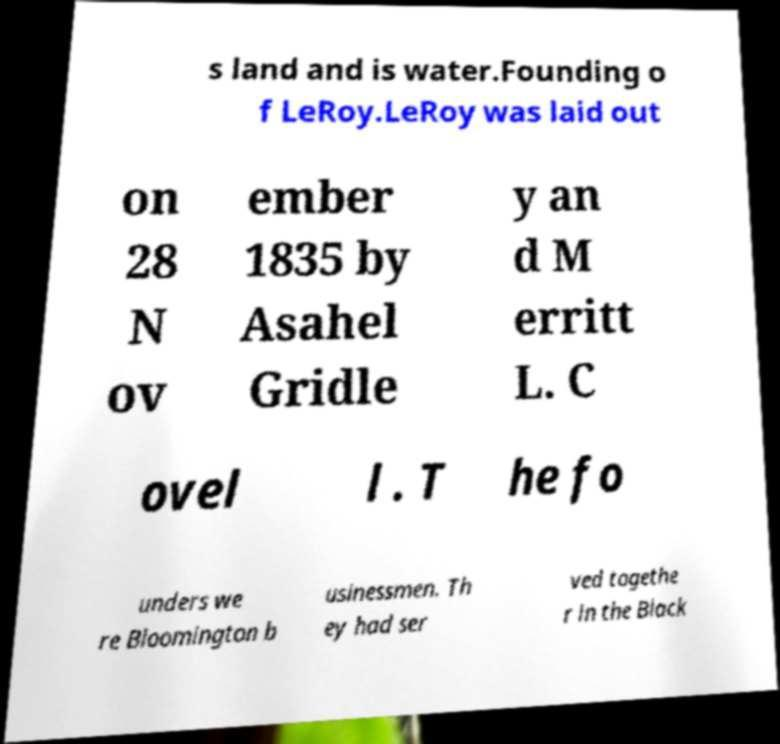Please read and relay the text visible in this image. What does it say? s land and is water.Founding o f LeRoy.LeRoy was laid out on 28 N ov ember 1835 by Asahel Gridle y an d M erritt L. C ovel l . T he fo unders we re Bloomington b usinessmen. Th ey had ser ved togethe r in the Black 